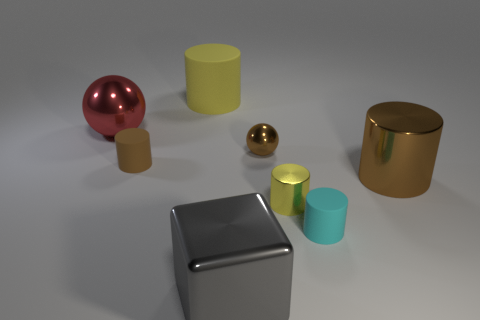Subtract all purple cylinders. Subtract all purple spheres. How many cylinders are left? 5 Add 1 large metallic spheres. How many objects exist? 9 Subtract all cylinders. How many objects are left? 3 Subtract all cyan matte things. Subtract all tiny cyan things. How many objects are left? 6 Add 5 small spheres. How many small spheres are left? 6 Add 3 big metallic spheres. How many big metallic spheres exist? 4 Subtract 0 cyan cubes. How many objects are left? 8 